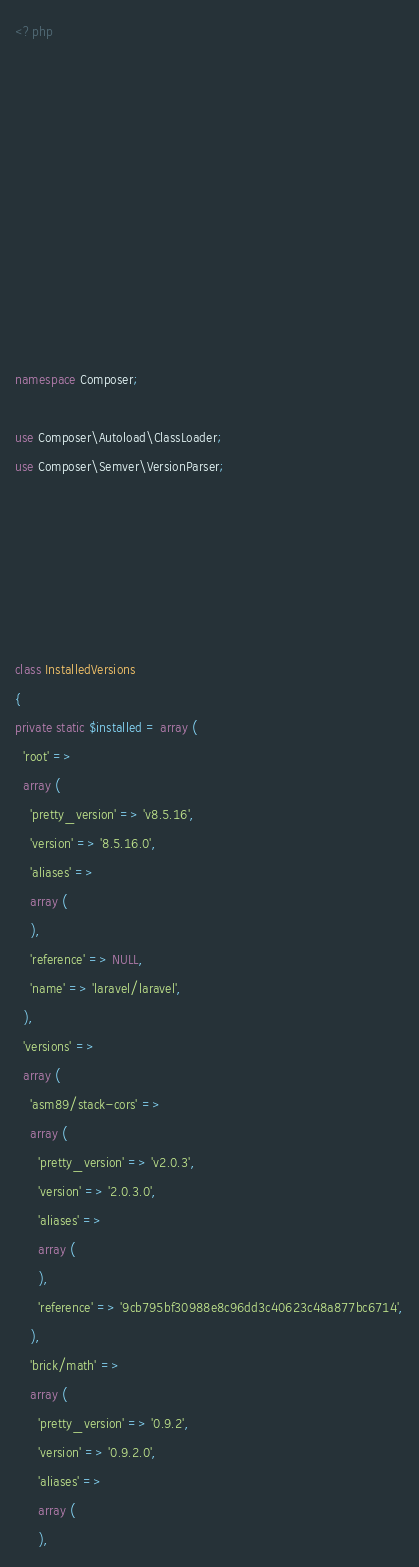<code> <loc_0><loc_0><loc_500><loc_500><_PHP_><?php











namespace Composer;

use Composer\Autoload\ClassLoader;
use Composer\Semver\VersionParser;






class InstalledVersions
{
private static $installed = array (
  'root' => 
  array (
    'pretty_version' => 'v8.5.16',
    'version' => '8.5.16.0',
    'aliases' => 
    array (
    ),
    'reference' => NULL,
    'name' => 'laravel/laravel',
  ),
  'versions' => 
  array (
    'asm89/stack-cors' => 
    array (
      'pretty_version' => 'v2.0.3',
      'version' => '2.0.3.0',
      'aliases' => 
      array (
      ),
      'reference' => '9cb795bf30988e8c96dd3c40623c48a877bc6714',
    ),
    'brick/math' => 
    array (
      'pretty_version' => '0.9.2',
      'version' => '0.9.2.0',
      'aliases' => 
      array (
      ),</code> 